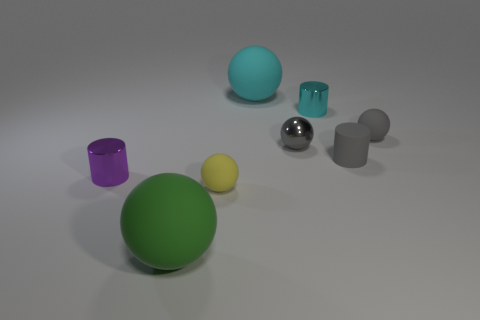Subtract all red balls. Subtract all red cylinders. How many balls are left? 5 Add 1 big brown cylinders. How many objects exist? 9 Subtract all spheres. How many objects are left? 3 Add 1 cyan rubber cubes. How many cyan rubber cubes exist? 1 Subtract 1 purple cylinders. How many objects are left? 7 Subtract all tiny gray cylinders. Subtract all large cyan matte objects. How many objects are left? 6 Add 6 tiny cyan things. How many tiny cyan things are left? 7 